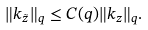Convert formula to latex. <formula><loc_0><loc_0><loc_500><loc_500>\| k _ { \tilde { z } } \| _ { q } \leq C ( q ) \| k _ { z } \| _ { q } .</formula> 